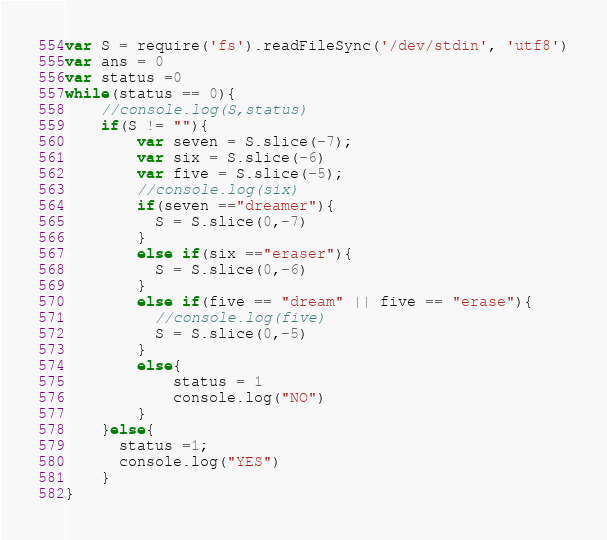<code> <loc_0><loc_0><loc_500><loc_500><_JavaScript_>var S = require('fs').readFileSync('/dev/stdin', 'utf8')
var ans = 0
var status =0
while(status == 0){
  	//console.log(S,status)
  	if(S != ""){
		var seven = S.slice(-7);
      	var six = S.slice(-6)
		var five = S.slice(-5);
      	//console.log(six)
		if(seven =="dreamer"){
	      S = S.slice(0,-7)
    	}
      	else if(six =="eraser"){
	      S = S.slice(0,-6)
    	}
		else if(five == "dream" || five == "erase"){
          //console.log(five)
	      S = S.slice(0,-5)
	    } 
  		else{
      		status = 1
      		console.log("NO")
    	}
    }else{
      status =1;
      console.log("YES")
    }
}
</code> 